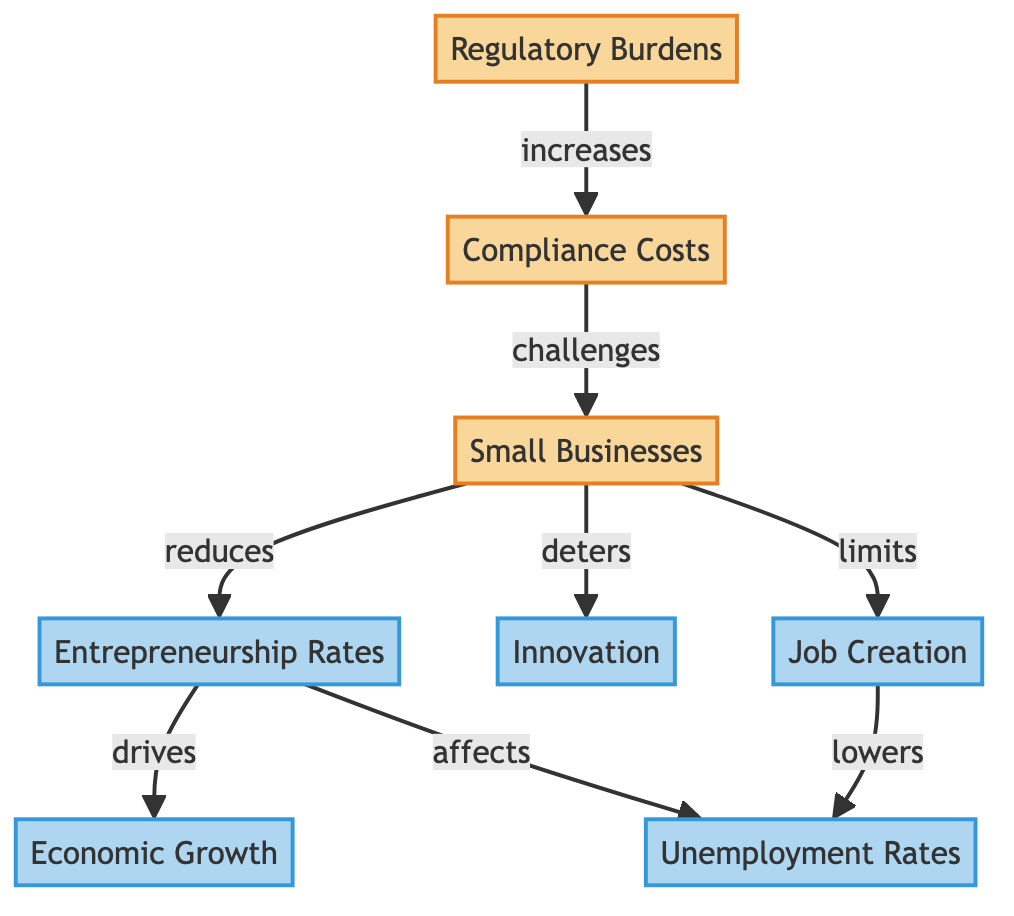What does an increase in regulatory burdens lead to? According to the diagram, an increase in regulatory burdens leads to an increase in compliance costs. This is directly indicated by the arrow connecting the 'Regulatory Burdens' node to the 'Compliance Costs' node.
Answer: Compliance costs How do small businesses affect entrepreneurship rates? The diagram shows that small businesses reduce entrepreneurship rates. This relationship is depicted with an arrow pointing from the 'Small Businesses' node to the 'Entrepreneurship Rates' node, indicating a negative impact.
Answer: Reduces What is the relationship between entrepreneurship rates and economic growth? The diagram presents a direct relationship where entrepreneurship rates drive economic growth. This is indicated by the arrow flowing from the 'Entrepreneurship Rates' node to the 'Economic Growth' node, suggesting a positive effect.
Answer: Drives How many nodes are there in the diagram? There are a total of 7 nodes in the diagram: Regulatory Burdens, Compliance Costs, Small Businesses, Entrepreneurship Rates, Innovation, Unemployment Rates, Economic Growth, and Job Creation.
Answer: 7 What impact do small businesses have on job creation? The diagram indicates that small businesses limit job creation, which is conveyed through the arrow from 'Small Businesses' to 'Job Creation'. This demonstrates that there's a hindrance or limitation effect.
Answer: Limits How does job creation affect unemployment rates? The diagram clearly shows that job creation lowers unemployment rates. This relationship is illustrated by the arrow pointing from the 'Job Creation' node to the 'Unemployment Rates' node, indicating a negative correlation with unemployment.
Answer: Lowers What do compliance costs challenge? It can be seen in the diagram that compliance costs challenge small businesses. This is represented by the arrow connecting the 'Compliance Costs' node to the 'Small Businesses' node, indicating that higher compliance costs pose challenges for these businesses.
Answer: Small businesses Which factor is directly affected by entrepreneurship rates? The diagram shows that entrepreneurship rates directly affect unemployment rates, as indicated by the arrow from the 'Entrepreneurship Rates' node to the 'Unemployment Rates' node. This highlights a connection between entrepreneurship and employment levels.
Answer: Unemployment rates 